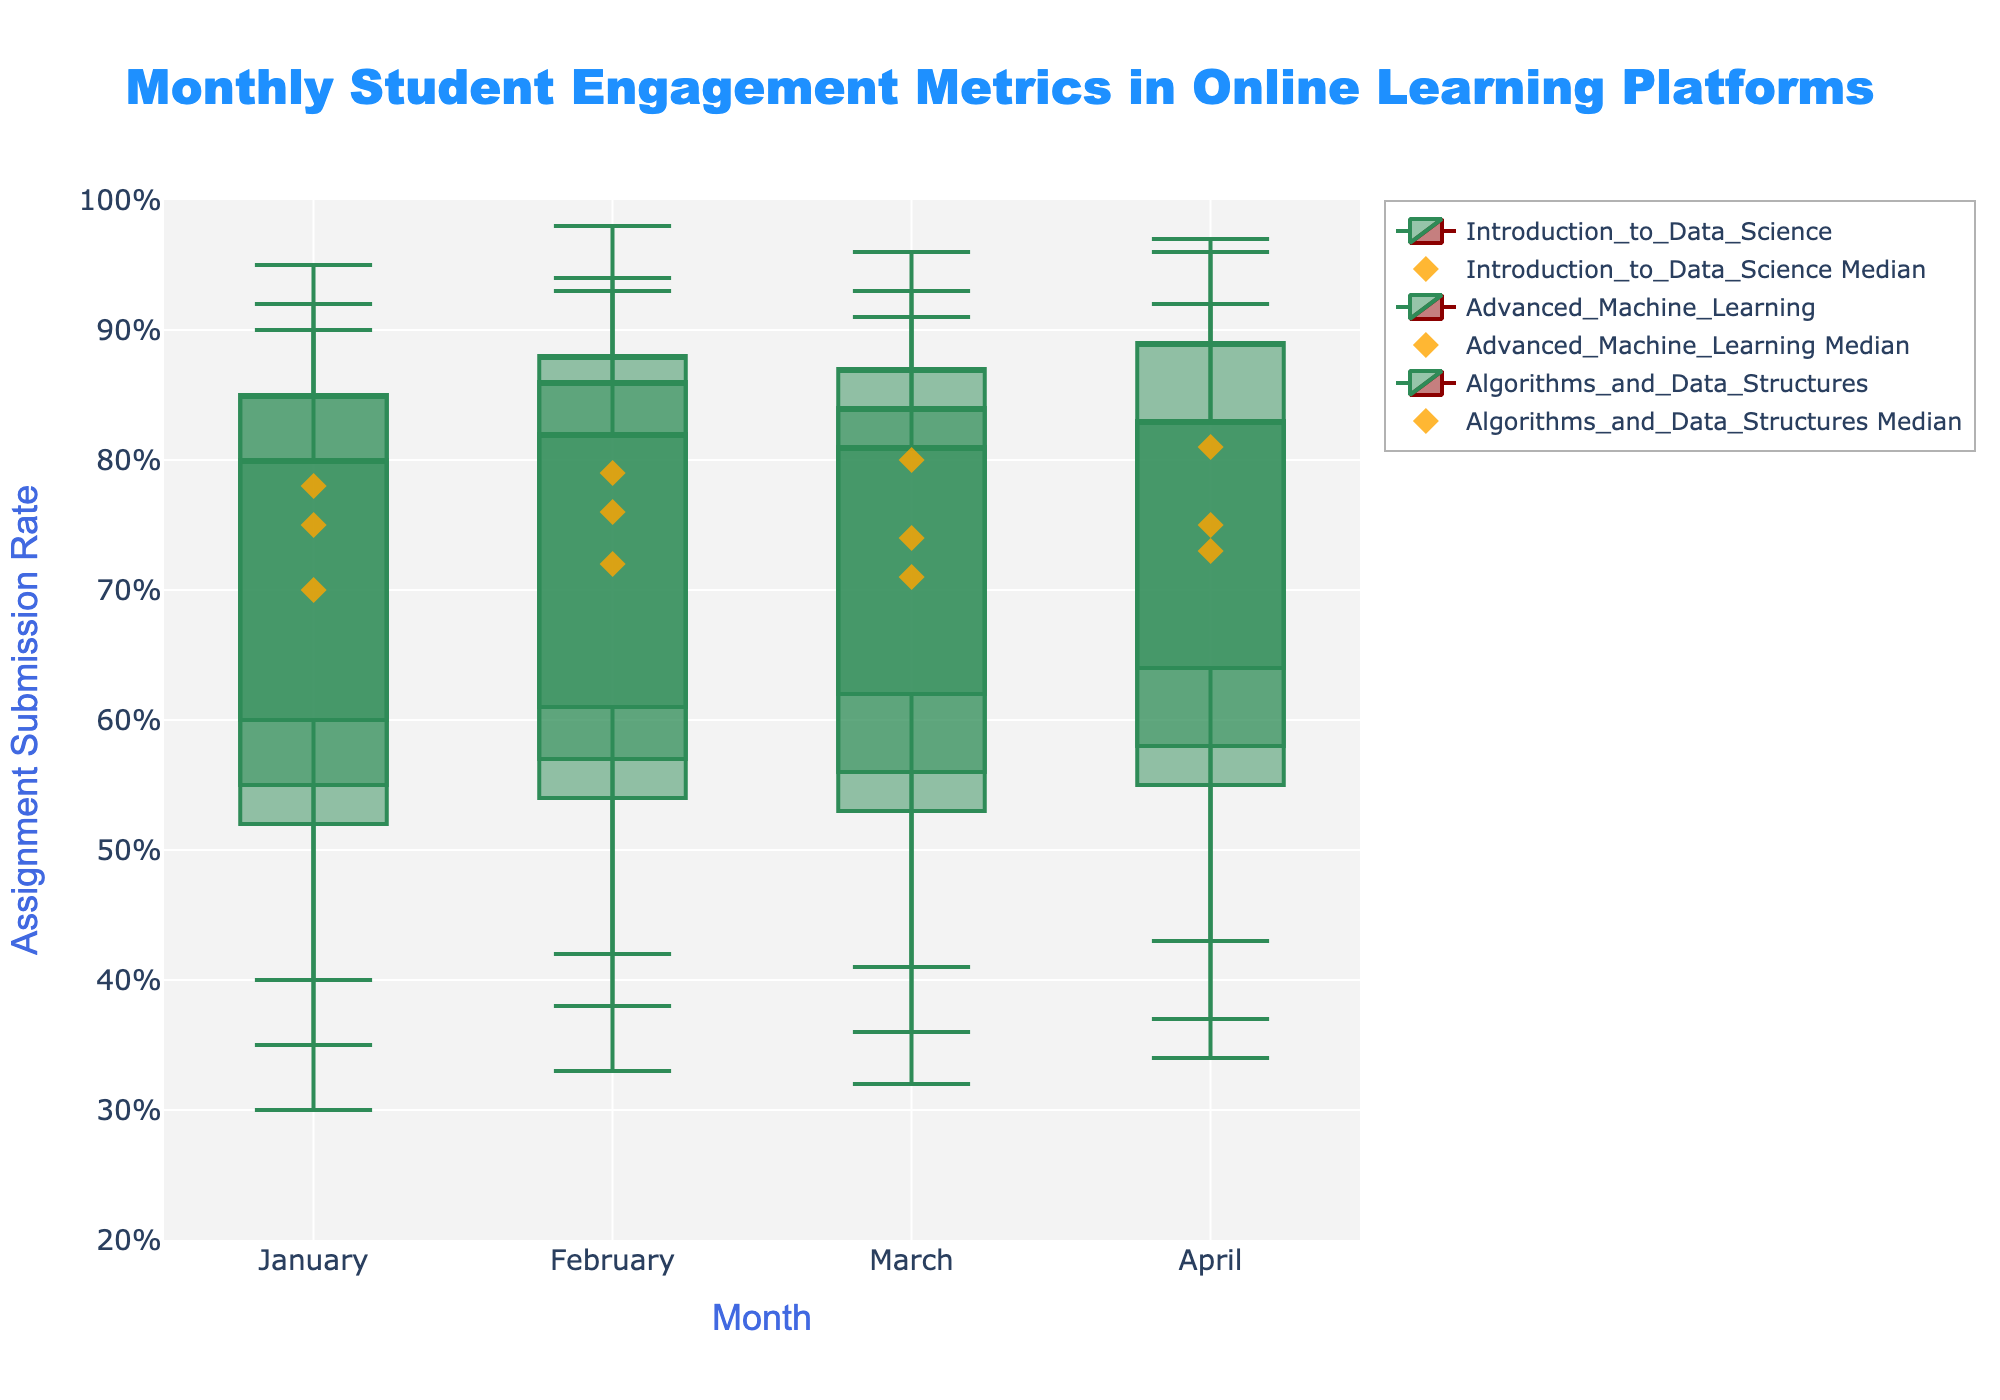What is the title of the plot? The title of the plot is "Monthly Student Engagement Metrics in Online Learning Platforms". The title is usually at the top center of the plot.
Answer: Monthly Student Engagement Metrics in Online Learning Platforms What does the y-axis represent? The y-axis represents the Assignment Submission Rate. This is indicated by the axis title on the y-axis.
Answer: Assignment Submission Rate Which course had the highest median submission rate in March? Look for the diamond markers representing the median values for each course in March. The course with the highest marker is "Algorithms_and_Data_Structures" with a median submission rate of 0.80.
Answer: Algorithms_and_Data_Structures In April, which course had a greater maximum submission rate: "Introduction to Data Science" or "Advanced Machine Learning"? Compare the upper whiskers of the candlesticks for both courses in April. "Introduction to Data Science" has a higher upper whisker (0.97) compared to "Advanced Machine Learning" (0.92).
Answer: Introduction_to_Data_Science How many different courses are represented in the plot? Count the unique candlestick traces in the plot. The courses are "Introduction to Data Science", "Advanced Machine Learning", and "Algorithms and Data Structures".
Answer: 3 What is the range of the assignment submission rate for "Algorithms and Data Structures" in February? The range is calculated by subtracting the minimum rate from the maximum rate for the course in February. The range = 0.94 - 0.42 = 0.52.
Answer: 0.52 Which month had the lowest minimum submission rate overall? Look for the lowest bottom whisker across all months. January has the lowest minimum submission rate (0.30 in "Advanced Machine Learning").
Answer: January In which month did "Introduction to Data Science" have the highest third quartile (Q3) submission rate? Look at the Q3 markers of "Introduction to Data Science". The highest Q3 submission rate is in February (0.86).
Answer: February What is the difference between the median submission rates of "Advanced Machine Learning" and "Algorithms_and_Data_Structures" in January? Take the median submission rates for both courses in January. "Advanced Machine Learning" has a median rate of 0.70, and "Algorithms_and_Data_Structures" has a median rate of 0.78. The difference = 0.78 - 0.70 = 0.08.
Answer: 0.08 